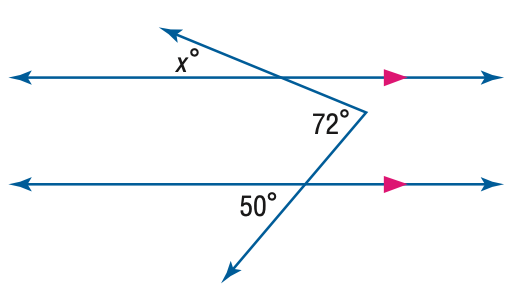Answer the mathemtical geometry problem and directly provide the correct option letter.
Question: Find x. (Hint: Draw an auxiliary line).
Choices: A: 22 B: 36 C: 50 D: 72 A 